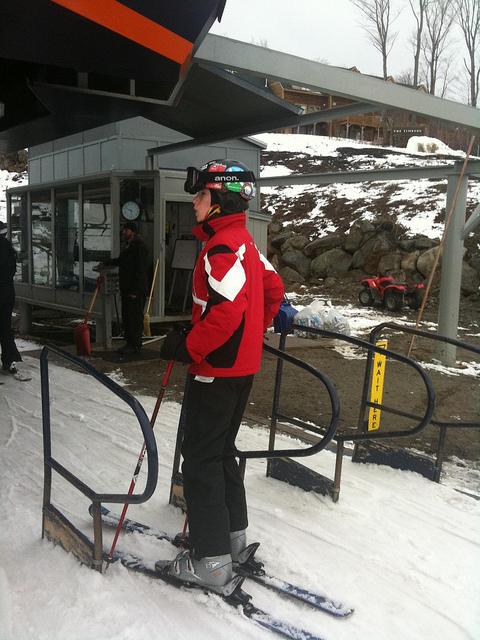What facility is there?
Give a very brief answer. Ski lift. Is this the entry to a ski lift?
Answer briefly. Yes. How many people are on the red ATV?
Concise answer only. 0. 